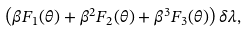Convert formula to latex. <formula><loc_0><loc_0><loc_500><loc_500>\left ( \beta F _ { 1 } ( \theta ) + \beta ^ { 2 } F _ { 2 } ( \theta ) + \beta ^ { 3 } F _ { 3 } ( \theta ) \right ) \delta \lambda ,</formula> 